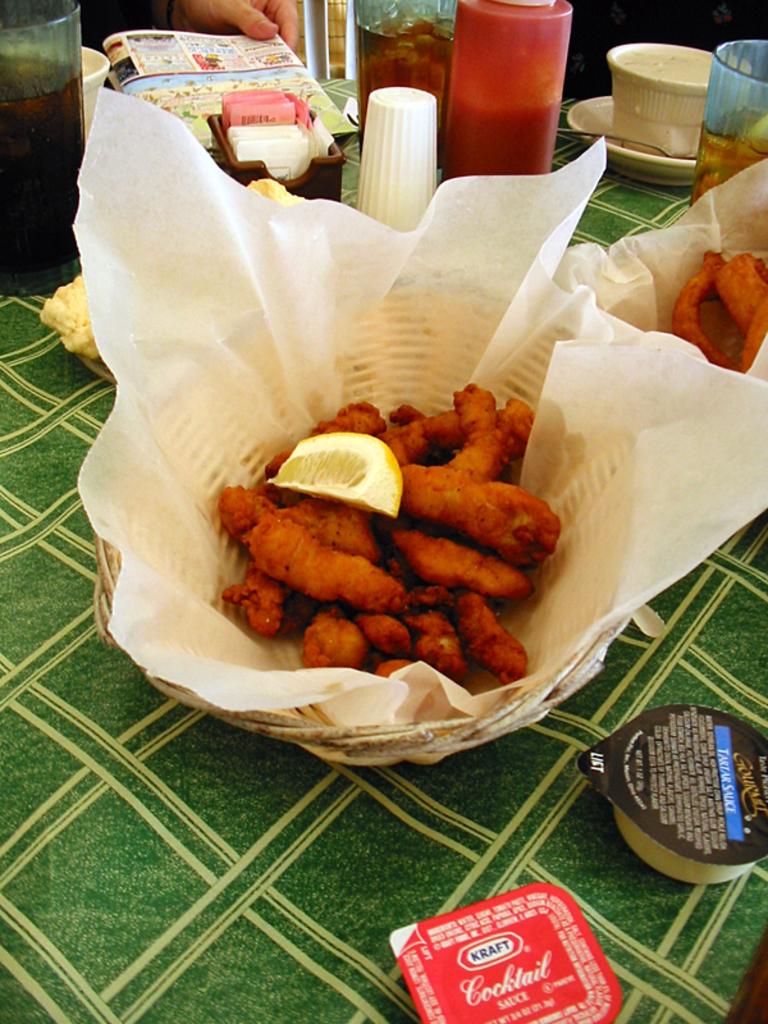Who makes whatever is in that red package?
Make the answer very short. Kraft. What is in the red package?
Make the answer very short. Cocktail sauce. 